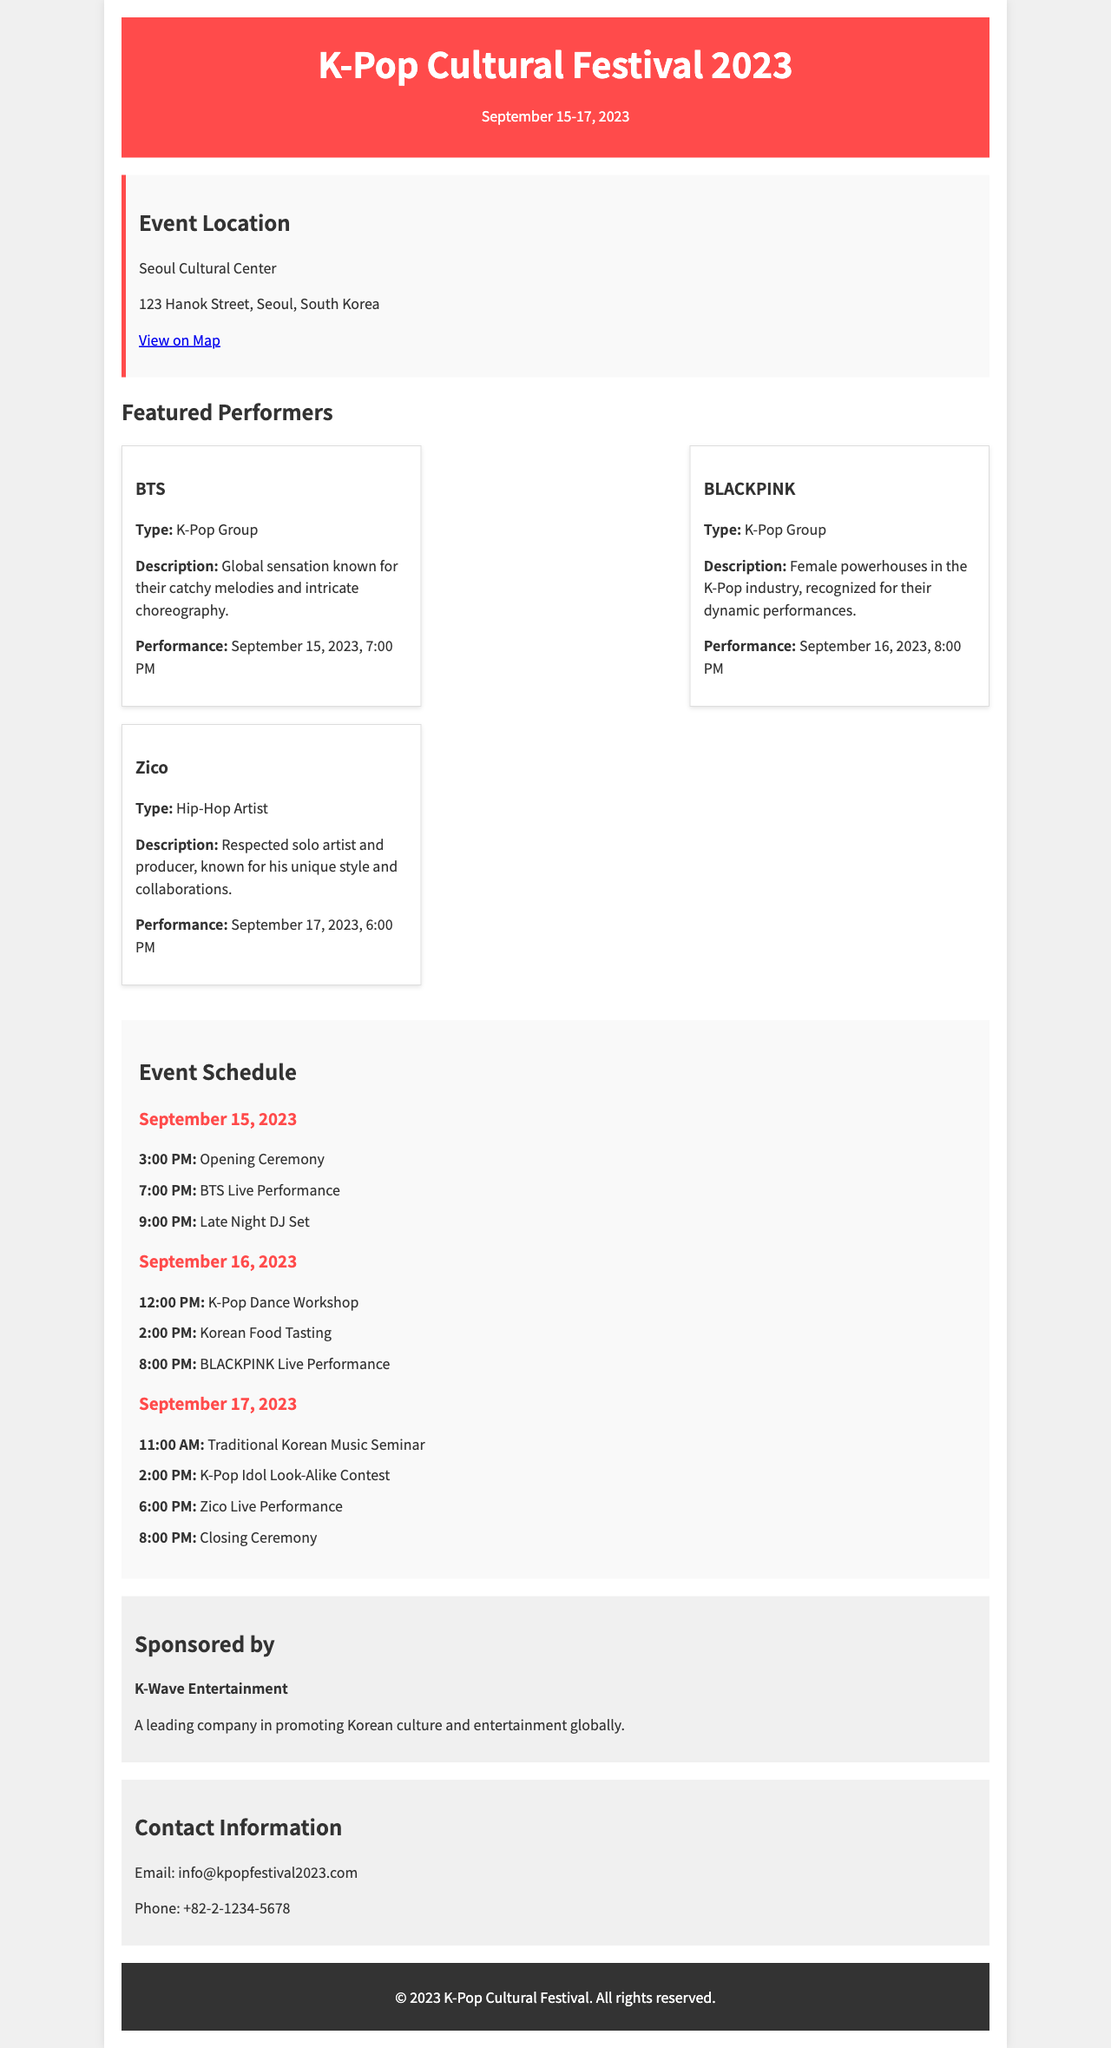What are the dates of the festival? The festival spans from September 15 to September 17, 2023.
Answer: September 15-17, 2023 Where is the event located? The event is held at the Seoul Cultural Center.
Answer: Seoul Cultural Center Who is performing on September 16, 2023? The performer scheduled for that date is BLACKPINK.
Answer: BLACKPINK What time does Zico's performance start? Zico's live performance is set for 6:00 PM on September 17, 2023.
Answer: 6:00 PM What type of event is scheduled for September 15, 2023, at 3:00 PM? An Opening Ceremony is taking place at that time.
Answer: Opening Ceremony How many performers are listed in the document? There are three featured performers mentioned in the document.
Answer: Three What type of company is K-Wave Entertainment? K-Wave Entertainment is a leading company in promoting Korean culture and entertainment globally.
Answer: A leading company Which performer is described as a Hip-Hop Artist? The performer identified as a Hip-Hop Artist is Zico.
Answer: Zico What is the contact email for the festival? The contact email provided is info@kpopfestival2023.com.
Answer: info@kpopfestival2023.com 